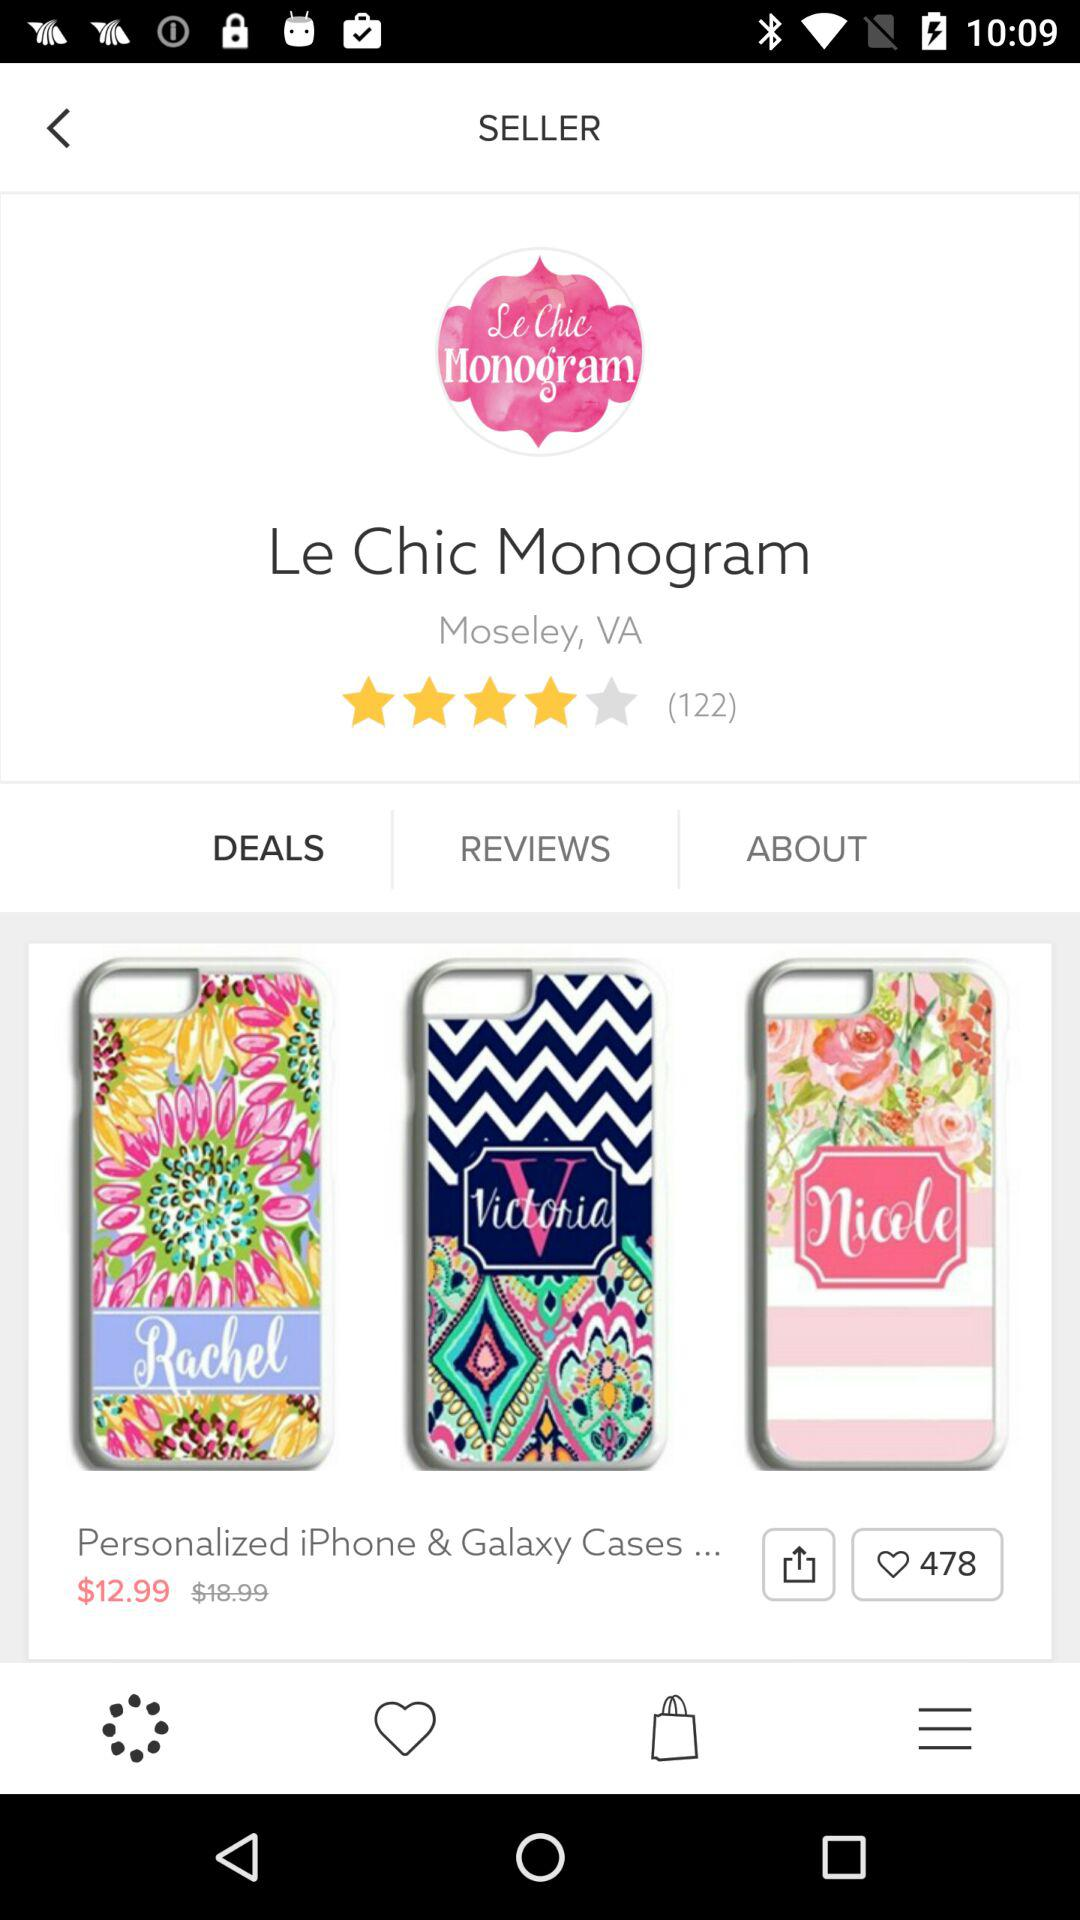What is the rating of "Le Chic Monogram"? The rating is 4 stars. 